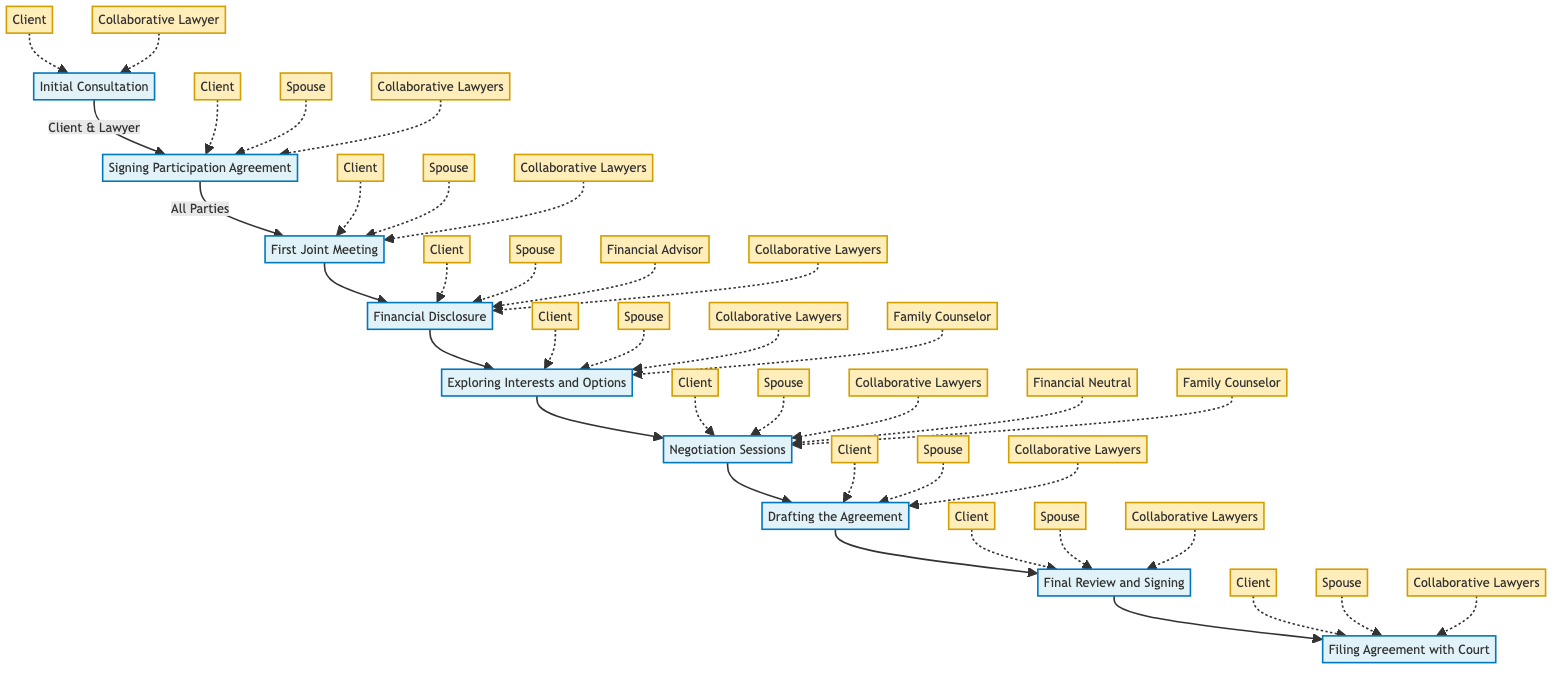What is the first step in the Collaborative Law Process? The diagram indicates that the first step in the Collaborative Law Process is the Initial Consultation. This is the starting point where each party meets with their collaborative lawyer.
Answer: Initial Consultation How many steps are involved in the process? By counting the steps in the flowchart, we can see there are a total of eight distinct steps from the Initial Consultation to Filing Agreement with Court.
Answer: Eight What do parties do in the First Joint Meeting? According to the flowchart, in the First Joint Meeting, all parties meet to outline issues, set goals, and create an agenda for future meetings. This is a crucial step for establishing a collaborative framework.
Answer: Outline issues, set goals, and create an agenda Which parties are involved in the Financial Disclosure step? The flowchart shows that the parties involved in Financial Disclosure are the Client, Spouse, Financial Advisor, and Collaborative Lawyers. This step focuses on transparency and fairness in negotiations.
Answer: Client, Spouse, Financial Advisor, Collaborative Lawyers How do the Negotiation Sessions aim to resolve disputes? The diagram illustrates that Negotiation Sessions are held with a focus on win-win solutions, maintaining a positive relationship between the parties. This reflects the core philosophy of collaborative law.
Answer: Win-win solutions and positive relationships Which is the step that directly follows Exploring Interests and Options? Following the step of Exploring Interests and Options in the flowchart, the next step is Negotiation Sessions, where the parties work through their interests to negotiate an agreement.
Answer: Negotiation Sessions What is the final step in the process? The last step indicated in the flowchart is Filing Agreement with Court, which finalizes the legal aspect of the negotiation and makes it binding.
Answer: Filing Agreement with Court Who signs the Participation Agreement? According to the flowchart, the Participation Agreement is signed by the Client, Spouse, and Collaborative Lawyers. This step is important for commitment to the process.
Answer: Client, Spouse, Collaborative Lawyers During which step do parties brainstorm potential solutions? The flowchart clearly specifies that the brainstorming of potential solutions occurs during the Exploring Interests and Options step, where needs and concerns of both parties are discussed.
Answer: Exploring Interests and Options 